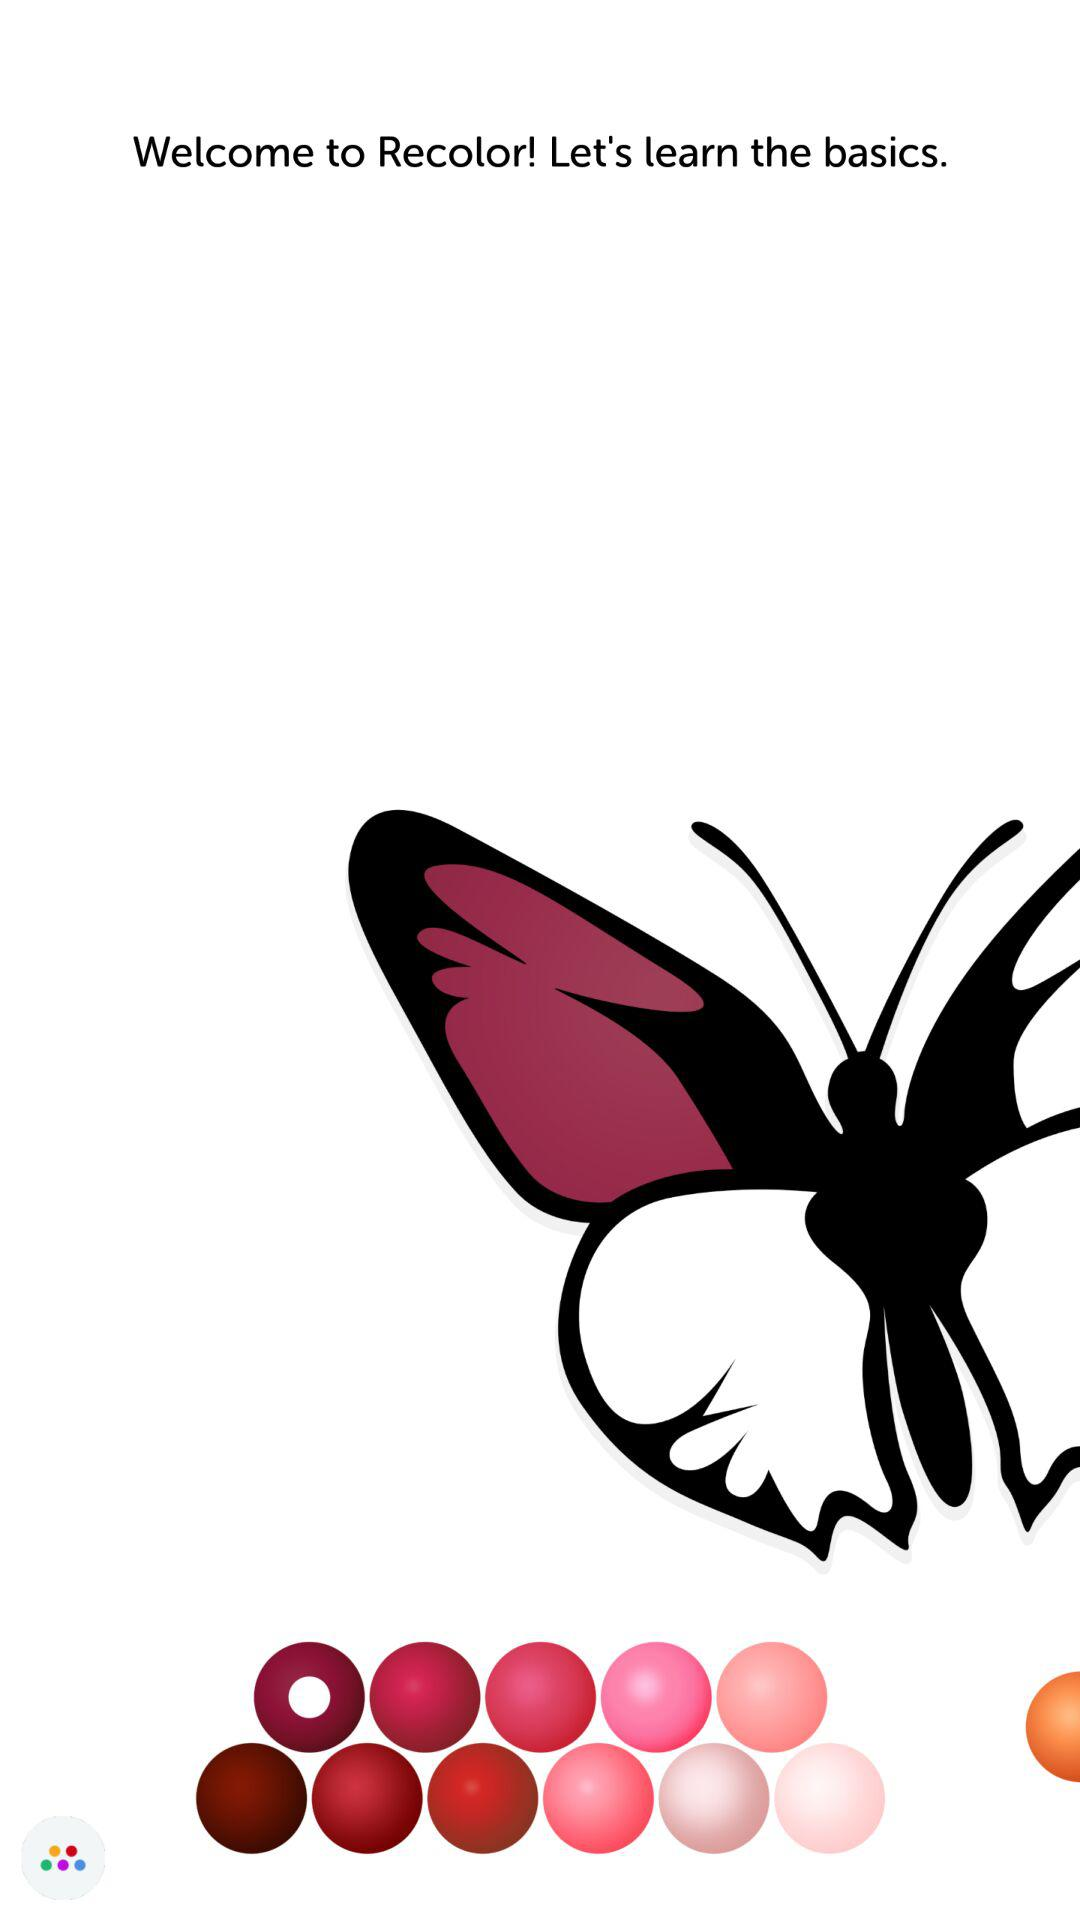What is the name of the application? The name of the application is "Recolor". 